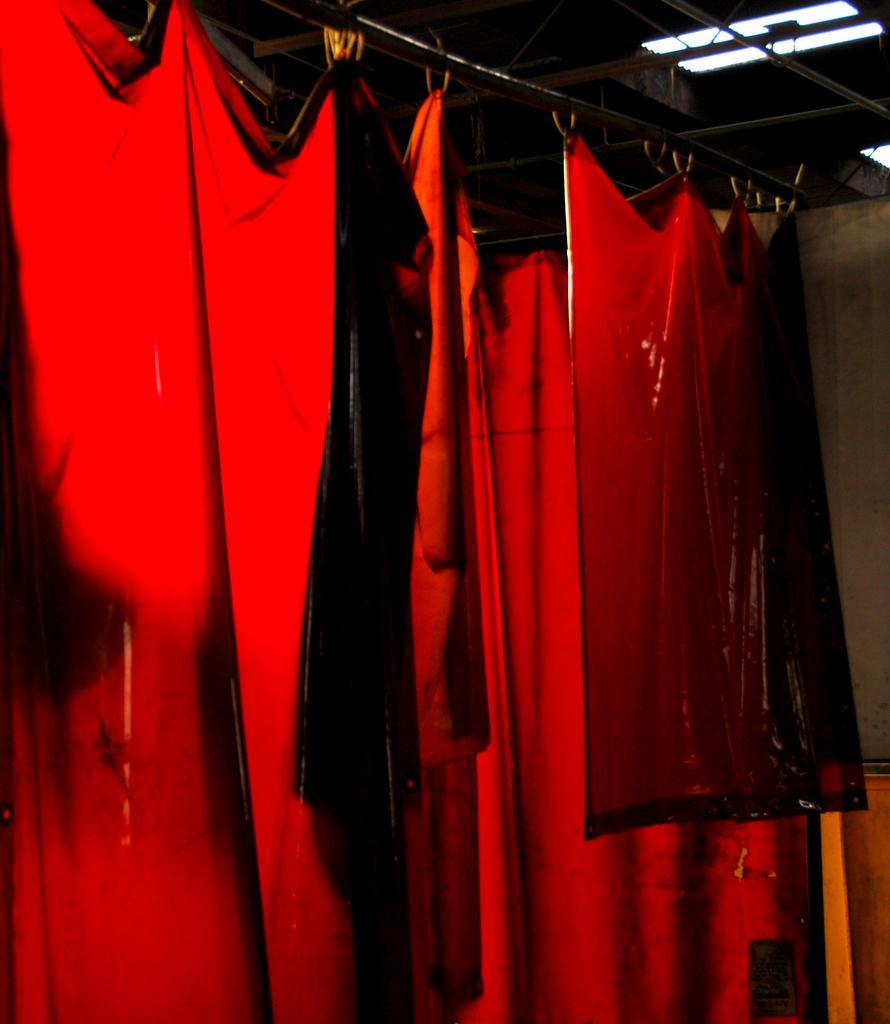Could you give a brief overview of what you see in this image? In this image, we can see curtains. There are lights in the top right of the image. 